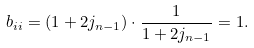<formula> <loc_0><loc_0><loc_500><loc_500>b _ { i i } = ( 1 + 2 j _ { n - 1 } ) \cdot \frac { 1 } { 1 + 2 j _ { n - 1 } } = 1 .</formula> 